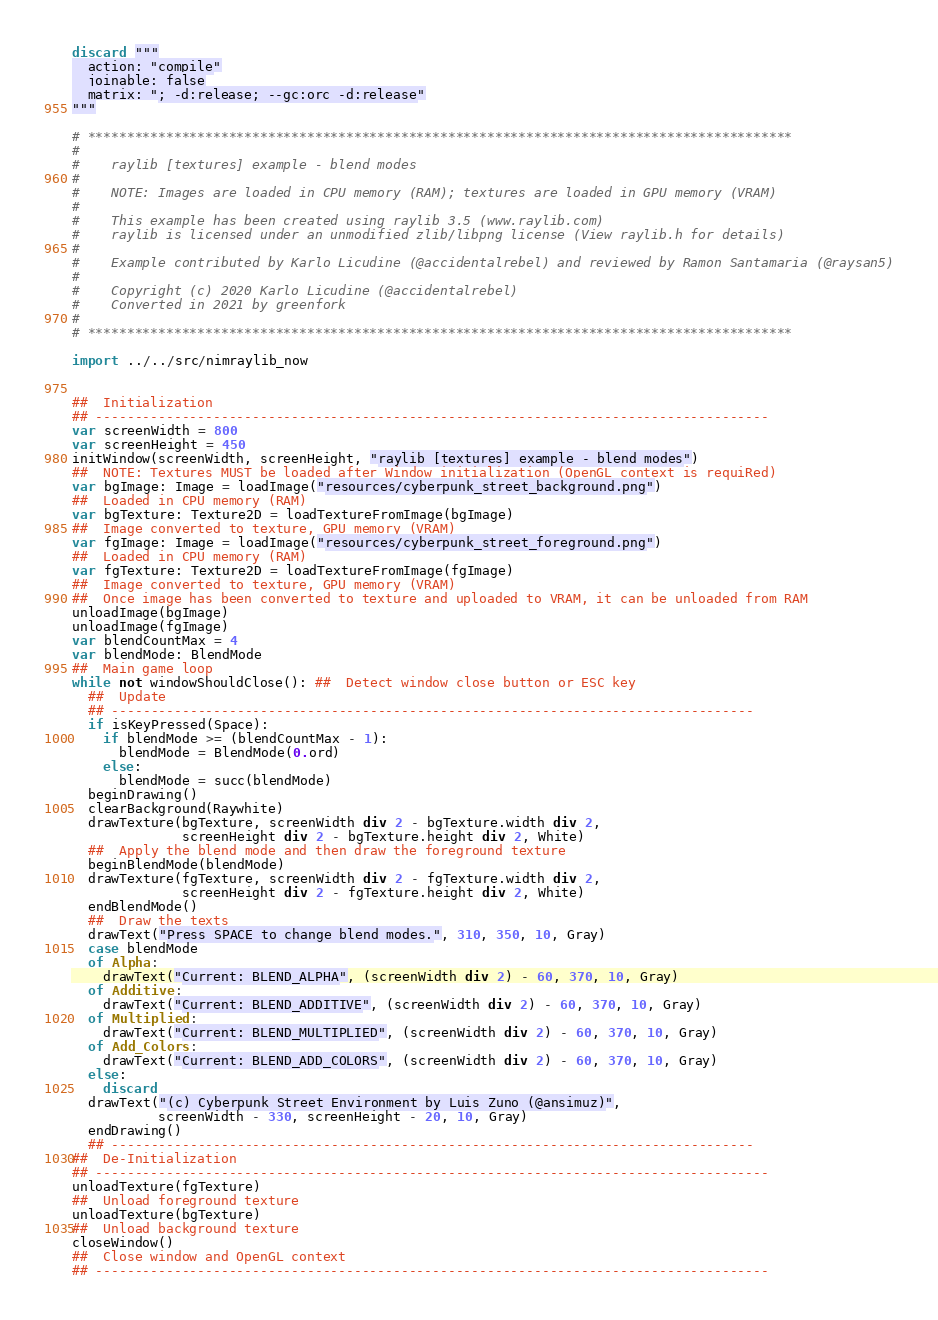<code> <loc_0><loc_0><loc_500><loc_500><_Nim_>discard """
  action: "compile"
  joinable: false
  matrix: "; -d:release; --gc:orc -d:release"
"""

# ******************************************************************************************
#
#    raylib [textures] example - blend modes
#
#    NOTE: Images are loaded in CPU memory (RAM); textures are loaded in GPU memory (VRAM)
#
#    This example has been created using raylib 3.5 (www.raylib.com)
#    raylib is licensed under an unmodified zlib/libpng license (View raylib.h for details)
#
#    Example contributed by Karlo Licudine (@accidentalrebel) and reviewed by Ramon Santamaria (@raysan5)
#
#    Copyright (c) 2020 Karlo Licudine (@accidentalrebel)
#    Converted in 2021 by greenfork
#
# ******************************************************************************************

import ../../src/nimraylib_now


##  Initialization
## --------------------------------------------------------------------------------------
var screenWidth = 800
var screenHeight = 450
initWindow(screenWidth, screenHeight, "raylib [textures] example - blend modes")
##  NOTE: Textures MUST be loaded after Window initialization (OpenGL context is requiRed)
var bgImage: Image = loadImage("resources/cyberpunk_street_background.png")
##  Loaded in CPU memory (RAM)
var bgTexture: Texture2D = loadTextureFromImage(bgImage)
##  Image converted to texture, GPU memory (VRAM)
var fgImage: Image = loadImage("resources/cyberpunk_street_foreground.png")
##  Loaded in CPU memory (RAM)
var fgTexture: Texture2D = loadTextureFromImage(fgImage)
##  Image converted to texture, GPU memory (VRAM)
##  Once image has been converted to texture and uploaded to VRAM, it can be unloaded from RAM
unloadImage(bgImage)
unloadImage(fgImage)
var blendCountMax = 4
var blendMode: BlendMode
##  Main game loop
while not windowShouldClose(): ##  Detect window close button or ESC key
  ##  Update
  ## ----------------------------------------------------------------------------------
  if isKeyPressed(Space):
    if blendMode >= (blendCountMax - 1):
      blendMode = BlendMode(0.ord)
    else:
      blendMode = succ(blendMode)
  beginDrawing()
  clearBackground(Raywhite)
  drawTexture(bgTexture, screenWidth div 2 - bgTexture.width div 2,
              screenHeight div 2 - bgTexture.height div 2, White)
  ##  Apply the blend mode and then draw the foreground texture
  beginBlendMode(blendMode)
  drawTexture(fgTexture, screenWidth div 2 - fgTexture.width div 2,
              screenHeight div 2 - fgTexture.height div 2, White)
  endBlendMode()
  ##  Draw the texts
  drawText("Press SPACE to change blend modes.", 310, 350, 10, Gray)
  case blendMode
  of Alpha:
    drawText("Current: BLEND_ALPHA", (screenWidth div 2) - 60, 370, 10, Gray)
  of Additive:
    drawText("Current: BLEND_ADDITIVE", (screenWidth div 2) - 60, 370, 10, Gray)
  of Multiplied:
    drawText("Current: BLEND_MULTIPLIED", (screenWidth div 2) - 60, 370, 10, Gray)
  of Add_Colors:
    drawText("Current: BLEND_ADD_COLORS", (screenWidth div 2) - 60, 370, 10, Gray)
  else:
    discard
  drawText("(c) Cyberpunk Street Environment by Luis Zuno (@ansimuz)",
           screenWidth - 330, screenHeight - 20, 10, Gray)
  endDrawing()
  ## ----------------------------------------------------------------------------------
##  De-Initialization
## --------------------------------------------------------------------------------------
unloadTexture(fgTexture)
##  Unload foreground texture
unloadTexture(bgTexture)
##  Unload background texture
closeWindow()
##  Close window and OpenGL context
## --------------------------------------------------------------------------------------
</code> 